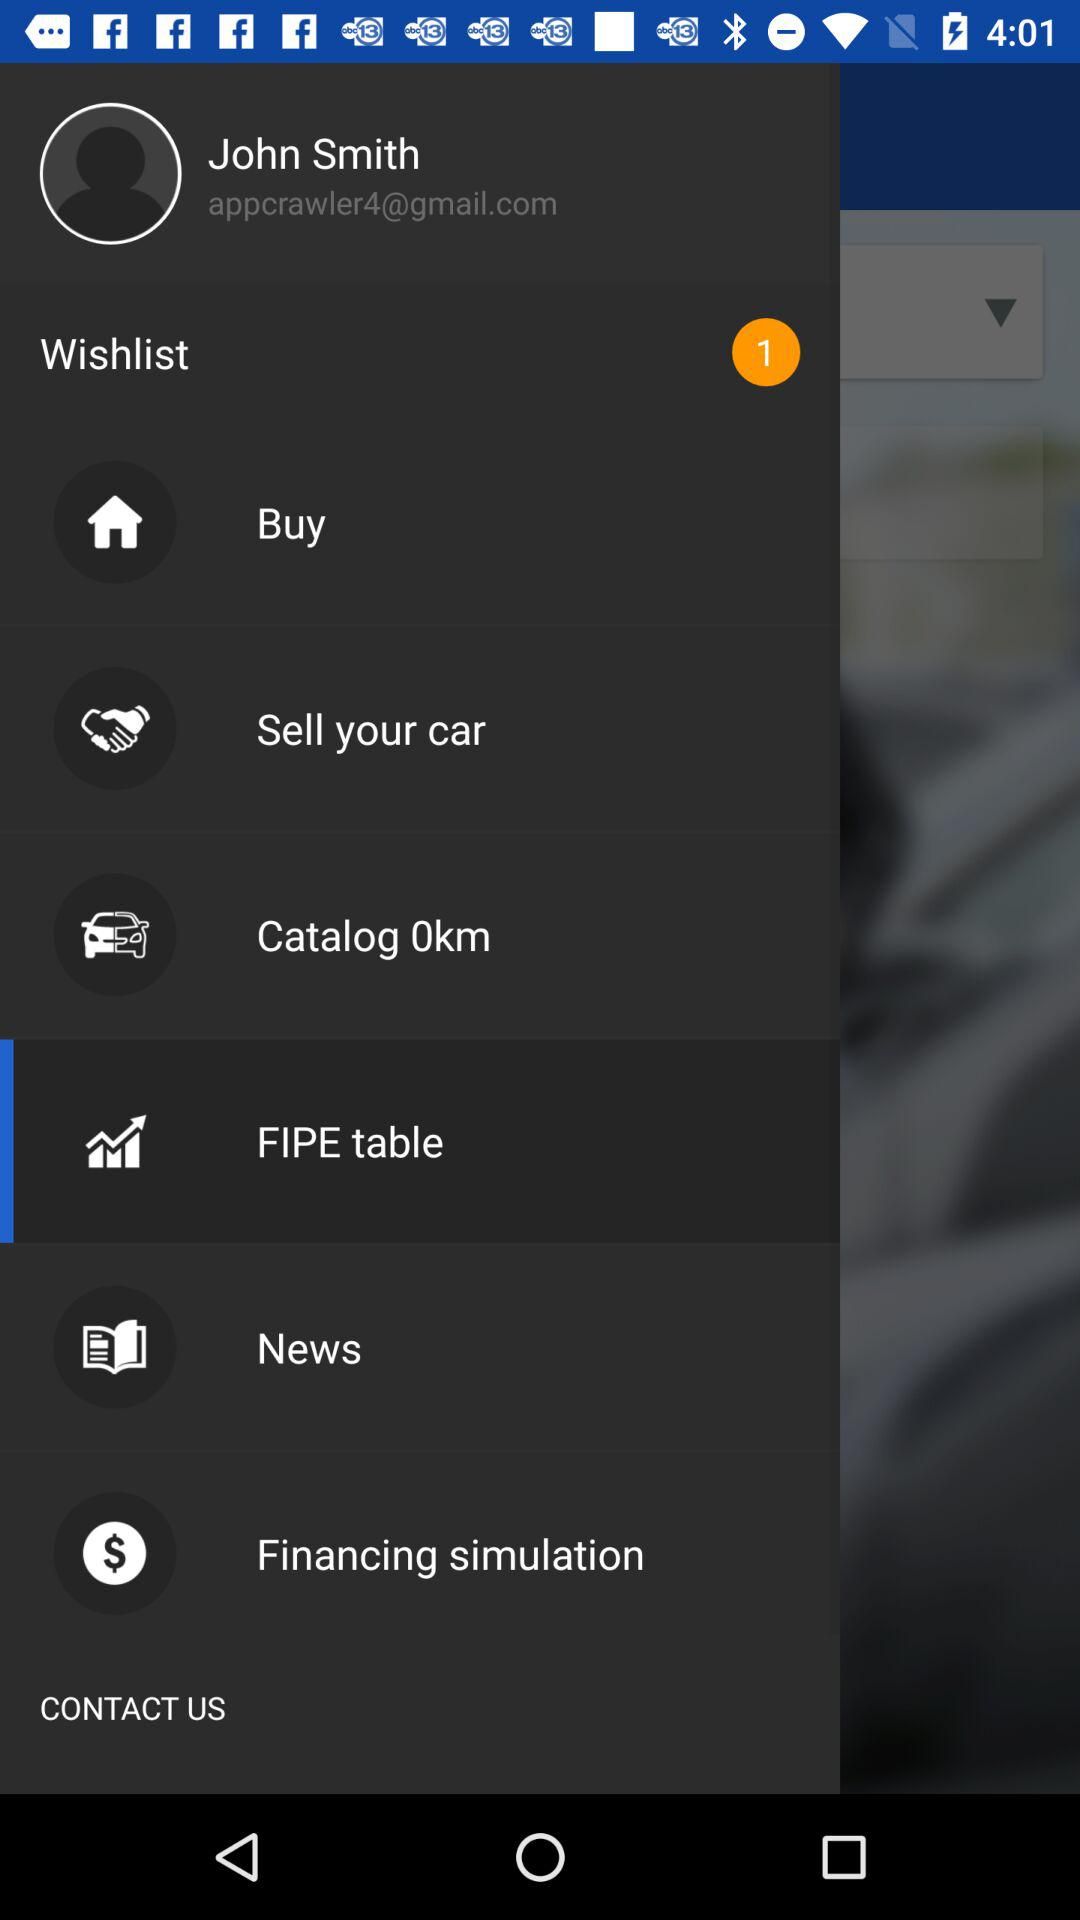What is the email address? The email address is appcrawler4@gmail.com. 